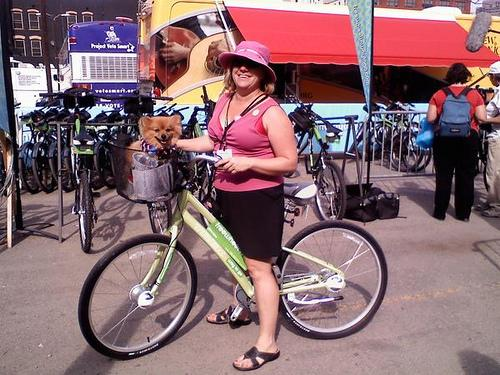Which wrong accessory has the woman worn for riding bike? Please explain your reasoning. shoes. Sandals aren't appropriate for pedaling with. 